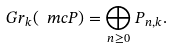Convert formula to latex. <formula><loc_0><loc_0><loc_500><loc_500>G r _ { k } ( \ m c P ) = \bigoplus _ { n \geq 0 } P _ { n , k } .</formula> 